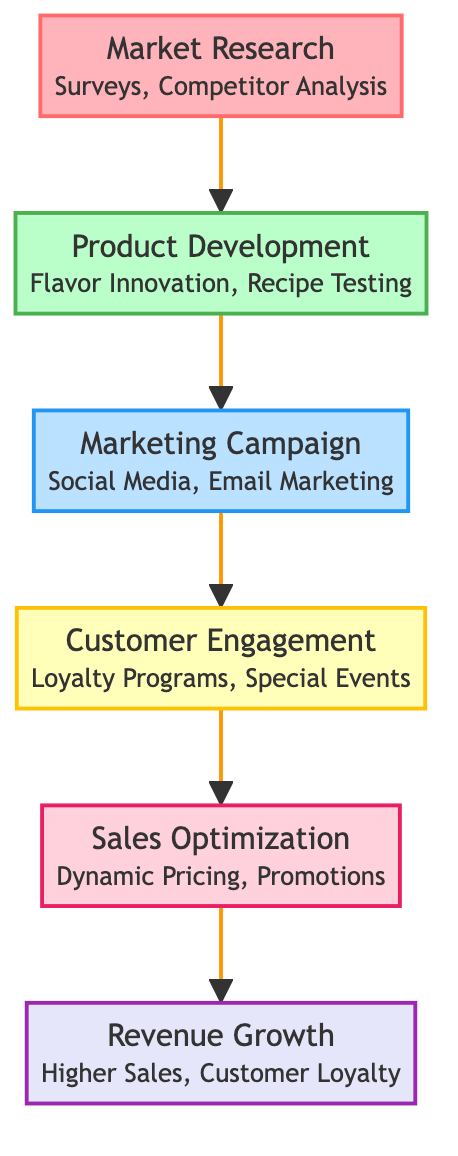What is the first step in the flow chart? The first step, or node, in the flow chart is "Market Research". It is the initial stage that leads to the subsequent steps in the process.
Answer: Market Research How many nodes are there in the flow chart? The flow chart consists of a total of six nodes, each representing a distinct stage in the sales increase strategy.
Answer: 6 Which node is directly before "Sales Optimization"? The node that comes directly before "Sales Optimization" is "Customer Engagement". This shows the sequential order of steps leading up to sales optimization.
Answer: Customer Engagement What is the last step in the flow chart? The last step in the flow chart is "Revenue Growth". This indicates the final outcome or goal of the process illustrated in the diagram.
Answer: Revenue Growth What examples are listed under "Marketing Campaign"? The examples listed under "Marketing Campaign" include "Social Media Advertising," "Email Marketing," and "Flyer Distribution," indicating the methods employed to promote new donut flavors.
Answer: Social Media Advertising, Email Marketing, Flyer Distribution What level is "Product Development"? "Product Development" is at level two in the flow chart, illustrating its position as the second step in the overall process.
Answer: 2 Which node follows "Market Research"? The node that follows "Market Research" is "Product Development". This indicates the flow of actions that continues after conducting research on the market.
Answer: Product Development What is the relationship between "Customer Engagement" and "Revenue Growth"? The relationship is sequential; "Customer Engagement" directly leads to "Sales Optimization," which in turn contributes to "Revenue Growth." This shows the path from engaging customers to achieving revenue growth.
Answer: Sequential relationship What are the examples associated with "Sales Optimization"? The examples associated with "Sales Optimization" are "Dynamic Pricing," "Seasonal Promotions," and "Outlet Expansion," which describe strategies to increase sales effectively.
Answer: Dynamic Pricing, Seasonal Promotions, Outlet Expansion 